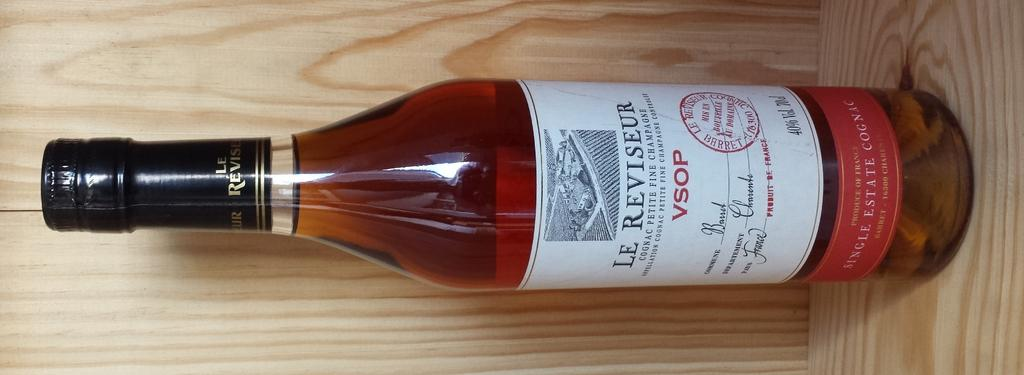<image>
Present a compact description of the photo's key features. A bottle of Le Reviseur wine is on a wooden shelf. 